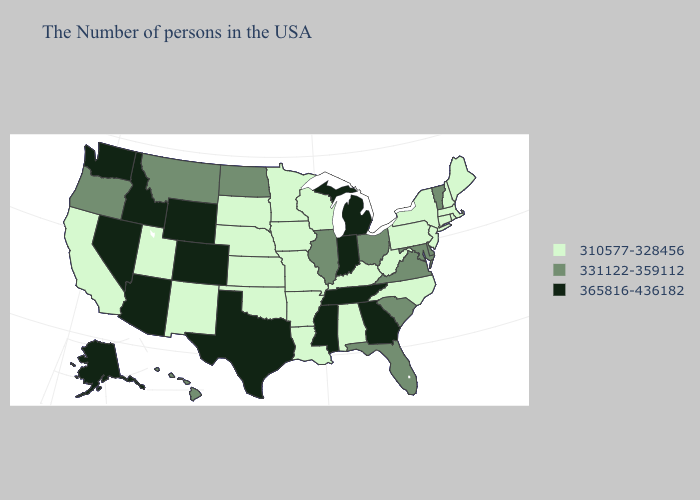How many symbols are there in the legend?
Short answer required. 3. Which states have the lowest value in the USA?
Quick response, please. Maine, Massachusetts, Rhode Island, New Hampshire, Connecticut, New York, New Jersey, Pennsylvania, North Carolina, West Virginia, Kentucky, Alabama, Wisconsin, Louisiana, Missouri, Arkansas, Minnesota, Iowa, Kansas, Nebraska, Oklahoma, South Dakota, New Mexico, Utah, California. Does Kentucky have the highest value in the South?
Be succinct. No. Name the states that have a value in the range 310577-328456?
Write a very short answer. Maine, Massachusetts, Rhode Island, New Hampshire, Connecticut, New York, New Jersey, Pennsylvania, North Carolina, West Virginia, Kentucky, Alabama, Wisconsin, Louisiana, Missouri, Arkansas, Minnesota, Iowa, Kansas, Nebraska, Oklahoma, South Dakota, New Mexico, Utah, California. Name the states that have a value in the range 365816-436182?
Keep it brief. Georgia, Michigan, Indiana, Tennessee, Mississippi, Texas, Wyoming, Colorado, Arizona, Idaho, Nevada, Washington, Alaska. What is the value of Kentucky?
Write a very short answer. 310577-328456. Name the states that have a value in the range 310577-328456?
Be succinct. Maine, Massachusetts, Rhode Island, New Hampshire, Connecticut, New York, New Jersey, Pennsylvania, North Carolina, West Virginia, Kentucky, Alabama, Wisconsin, Louisiana, Missouri, Arkansas, Minnesota, Iowa, Kansas, Nebraska, Oklahoma, South Dakota, New Mexico, Utah, California. What is the value of New York?
Short answer required. 310577-328456. Among the states that border Maryland , does Virginia have the lowest value?
Give a very brief answer. No. Name the states that have a value in the range 310577-328456?
Answer briefly. Maine, Massachusetts, Rhode Island, New Hampshire, Connecticut, New York, New Jersey, Pennsylvania, North Carolina, West Virginia, Kentucky, Alabama, Wisconsin, Louisiana, Missouri, Arkansas, Minnesota, Iowa, Kansas, Nebraska, Oklahoma, South Dakota, New Mexico, Utah, California. Name the states that have a value in the range 331122-359112?
Keep it brief. Vermont, Delaware, Maryland, Virginia, South Carolina, Ohio, Florida, Illinois, North Dakota, Montana, Oregon, Hawaii. What is the value of California?
Write a very short answer. 310577-328456. Does New Mexico have the lowest value in the West?
Short answer required. Yes. What is the value of New Mexico?
Give a very brief answer. 310577-328456. What is the value of Delaware?
Quick response, please. 331122-359112. 